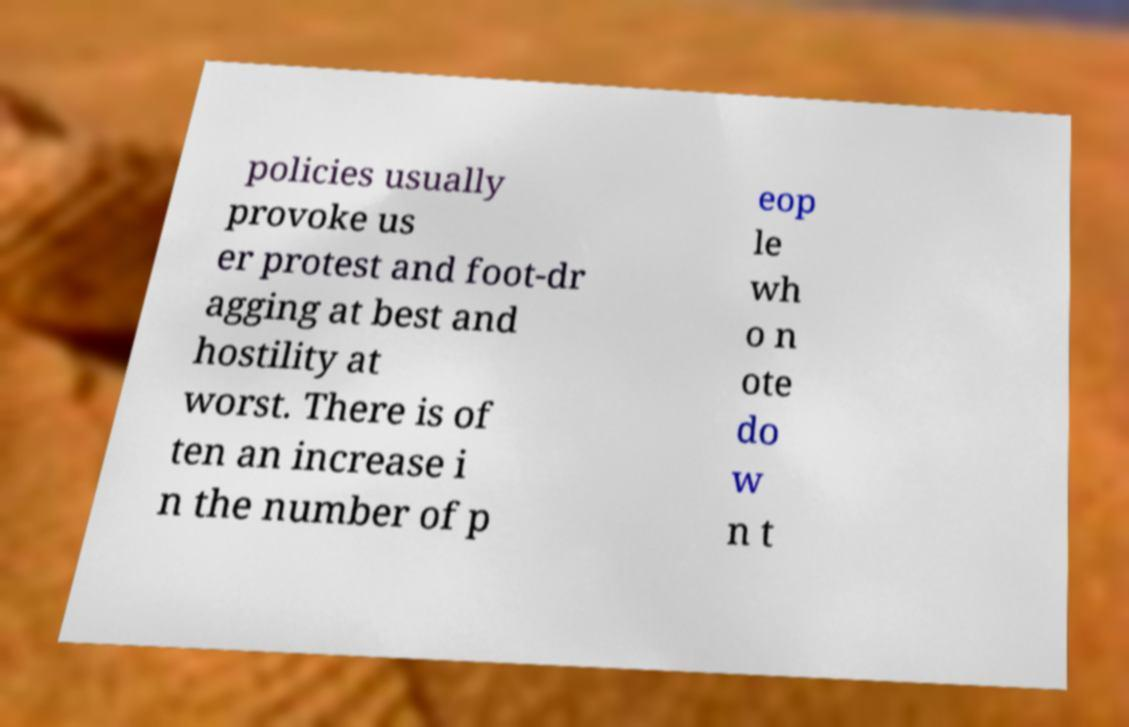Can you accurately transcribe the text from the provided image for me? policies usually provoke us er protest and foot-dr agging at best and hostility at worst. There is of ten an increase i n the number of p eop le wh o n ote do w n t 